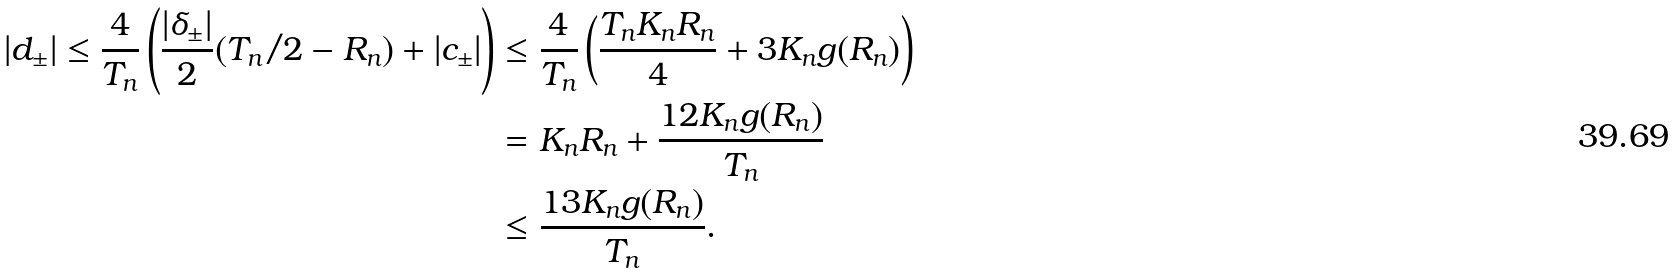<formula> <loc_0><loc_0><loc_500><loc_500>| d _ { \pm } | \leq \frac { 4 } { T _ { n } } \left ( \frac { | \delta _ { \pm } | } { 2 } ( T _ { n } / 2 - R _ { n } ) + | c _ { \pm } | \right ) & \leq \frac { 4 } { T _ { n } } \left ( \frac { T _ { n } K _ { n } R _ { n } } { 4 } + 3 K _ { n } g ( R _ { n } ) \right ) \\ & = K _ { n } R _ { n } + \frac { 1 2 K _ { n } g ( R _ { n } ) } { T _ { n } } \\ & \leq \frac { 1 3 K _ { n } g ( R _ { n } ) } { T _ { n } } .</formula> 